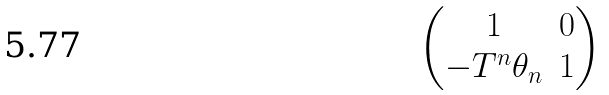<formula> <loc_0><loc_0><loc_500><loc_500>\begin{pmatrix} 1 & 0 \\ - T ^ { n } \theta _ { n } & 1 \end{pmatrix}</formula> 